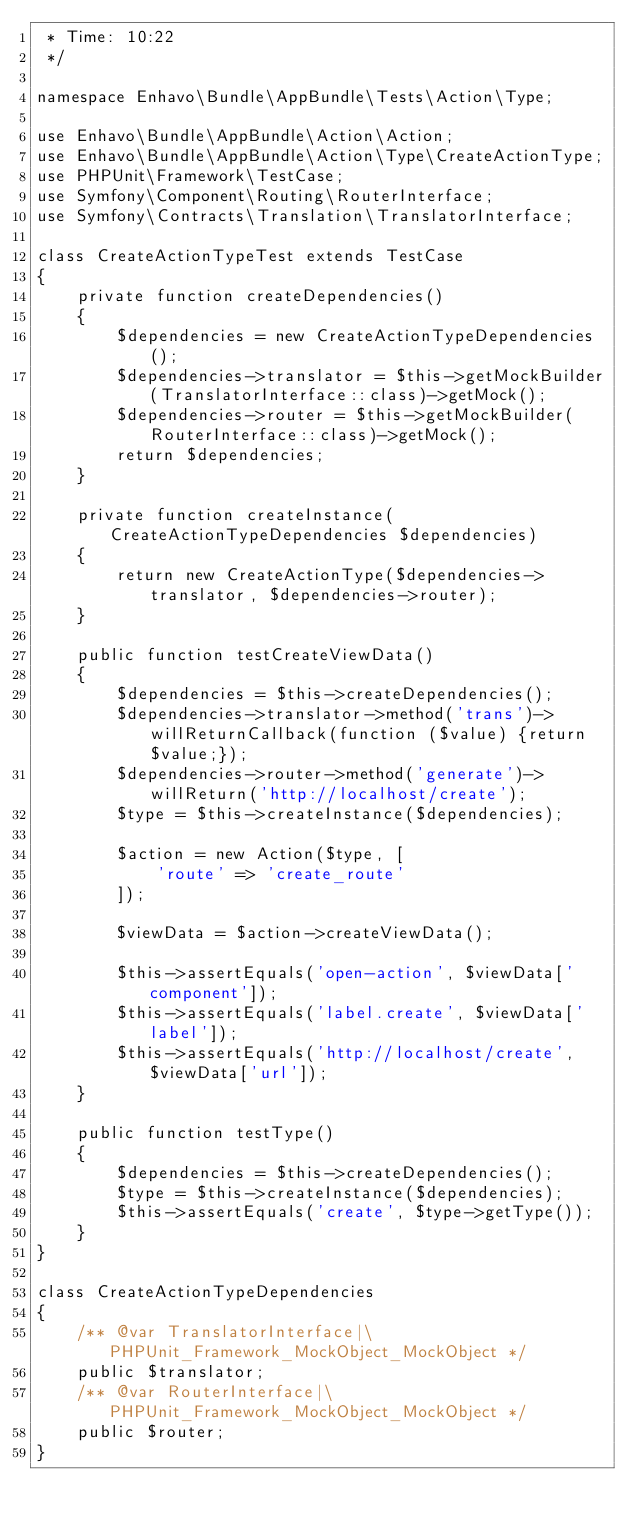<code> <loc_0><loc_0><loc_500><loc_500><_PHP_> * Time: 10:22
 */

namespace Enhavo\Bundle\AppBundle\Tests\Action\Type;

use Enhavo\Bundle\AppBundle\Action\Action;
use Enhavo\Bundle\AppBundle\Action\Type\CreateActionType;
use PHPUnit\Framework\TestCase;
use Symfony\Component\Routing\RouterInterface;
use Symfony\Contracts\Translation\TranslatorInterface;

class CreateActionTypeTest extends TestCase
{
    private function createDependencies()
    {
        $dependencies = new CreateActionTypeDependencies();
        $dependencies->translator = $this->getMockBuilder(TranslatorInterface::class)->getMock();
        $dependencies->router = $this->getMockBuilder(RouterInterface::class)->getMock();
        return $dependencies;
    }

    private function createInstance(CreateActionTypeDependencies $dependencies)
    {
        return new CreateActionType($dependencies->translator, $dependencies->router);
    }

    public function testCreateViewData()
    {
        $dependencies = $this->createDependencies();
        $dependencies->translator->method('trans')->willReturnCallback(function ($value) {return $value;});
        $dependencies->router->method('generate')->willReturn('http://localhost/create');
        $type = $this->createInstance($dependencies);

        $action = new Action($type, [
            'route' => 'create_route'
        ]);

        $viewData = $action->createViewData();

        $this->assertEquals('open-action', $viewData['component']);
        $this->assertEquals('label.create', $viewData['label']);
        $this->assertEquals('http://localhost/create', $viewData['url']);
    }

    public function testType()
    {
        $dependencies = $this->createDependencies();
        $type = $this->createInstance($dependencies);
        $this->assertEquals('create', $type->getType());
    }
}

class CreateActionTypeDependencies
{
    /** @var TranslatorInterface|\PHPUnit_Framework_MockObject_MockObject */
    public $translator;
    /** @var RouterInterface|\PHPUnit_Framework_MockObject_MockObject */
    public $router;
}
</code> 